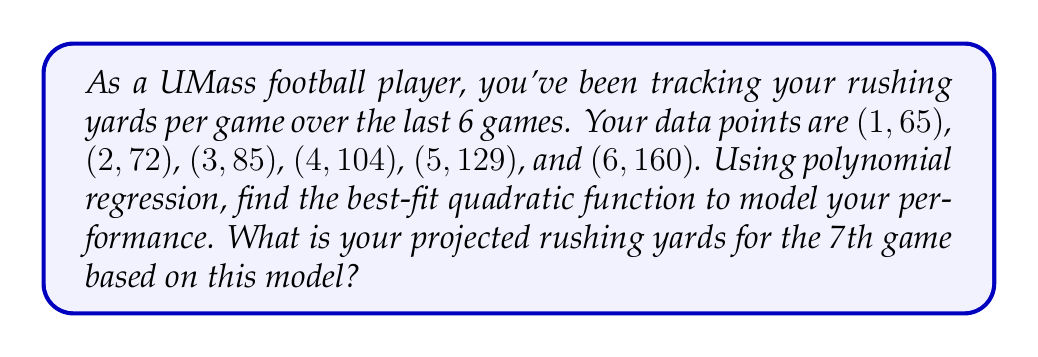Give your solution to this math problem. Let's approach this step-by-step:

1) For a quadratic function $f(x) = ax^2 + bx + c$, we need to find $a$, $b$, and $c$.

2) We'll use the least squares method to find these coefficients. This involves solving the following system of equations:

   $$\begin{cases}
   \sum y = an\sum x^2 + b\sum x + cn \\
   \sum xy = a\sum x^3 + b\sum x^2 + c\sum x \\
   \sum x^2y = a\sum x^4 + b\sum x^3 + c\sum x^2
   \end{cases}$$

3) First, let's calculate the necessary sums:
   $\sum x = 1 + 2 + 3 + 4 + 5 + 6 = 21$
   $\sum x^2 = 1 + 4 + 9 + 16 + 25 + 36 = 91$
   $\sum x^3 = 1 + 8 + 27 + 64 + 125 + 216 = 441$
   $\sum x^4 = 1 + 16 + 81 + 256 + 625 + 1296 = 2275$
   $\sum y = 65 + 72 + 85 + 104 + 129 + 160 = 615$
   $\sum xy = 65 + 144 + 255 + 416 + 645 + 960 = 2485$
   $\sum x^2y = 65 + 288 + 765 + 1664 + 3225 + 5760 = 11767$

4) Now we can set up our system of equations:
   $$\begin{cases}
   615 = 91a + 21b + 6c \\
   2485 = 441a + 91b + 21c \\
   11767 = 2275a + 441b + 91c
   \end{cases}$$

5) Solving this system (you can use a calculator or computer for this step), we get:
   $a \approx 4.0714$, $b \approx 3.5714$, $c \approx 58.3571$

6) Therefore, our quadratic function is:
   $f(x) \approx 4.0714x^2 + 3.5714x + 58.3571$

7) To project the rushing yards for the 7th game, we evaluate $f(7)$:
   $f(7) \approx 4.0714(7^2) + 3.5714(7) + 58.3571$
         $\approx 4.0714(49) + 3.5714(7) + 58.3571$
         $\approx 199.5 + 25 + 58.3571$
         $\approx 282.8571$

8) Rounding to the nearest yard, we project 283 rushing yards for the 7th game.
Answer: 283 yards 